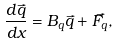<formula> <loc_0><loc_0><loc_500><loc_500>\frac { d \vec { q } } { d x } = B _ { q } \vec { q } + \vec { F _ { q } } ,</formula> 